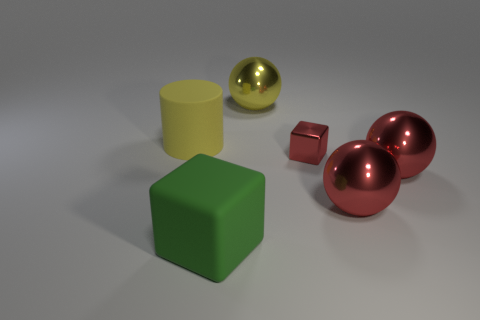Add 3 big blocks. How many objects exist? 9 Subtract all cylinders. How many objects are left? 5 Subtract 0 purple balls. How many objects are left? 6 Subtract all big gray metal blocks. Subtract all red metal things. How many objects are left? 3 Add 3 big metallic balls. How many big metallic balls are left? 6 Add 2 red metal cubes. How many red metal cubes exist? 3 